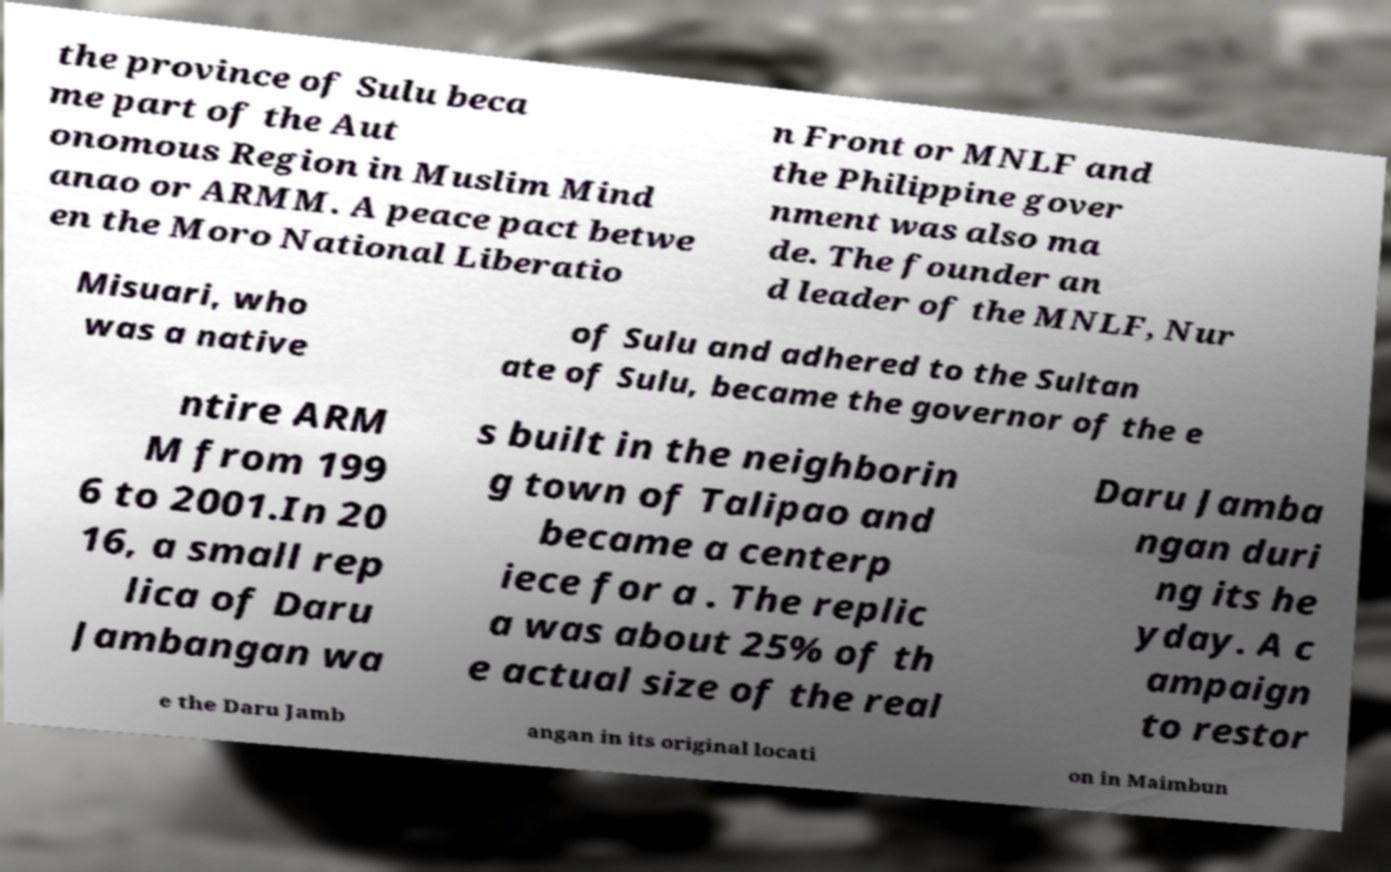Could you assist in decoding the text presented in this image and type it out clearly? the province of Sulu beca me part of the Aut onomous Region in Muslim Mind anao or ARMM. A peace pact betwe en the Moro National Liberatio n Front or MNLF and the Philippine gover nment was also ma de. The founder an d leader of the MNLF, Nur Misuari, who was a native of Sulu and adhered to the Sultan ate of Sulu, became the governor of the e ntire ARM M from 199 6 to 2001.In 20 16, a small rep lica of Daru Jambangan wa s built in the neighborin g town of Talipao and became a centerp iece for a . The replic a was about 25% of th e actual size of the real Daru Jamba ngan duri ng its he yday. A c ampaign to restor e the Daru Jamb angan in its original locati on in Maimbun 